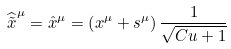<formula> <loc_0><loc_0><loc_500><loc_500>\widehat { \tilde { x } } ^ { \mu } = \hat { x } ^ { \mu } = \left ( x ^ { \mu } + s ^ { \mu } \right ) \frac { 1 } { \sqrt { C u + 1 } }</formula> 